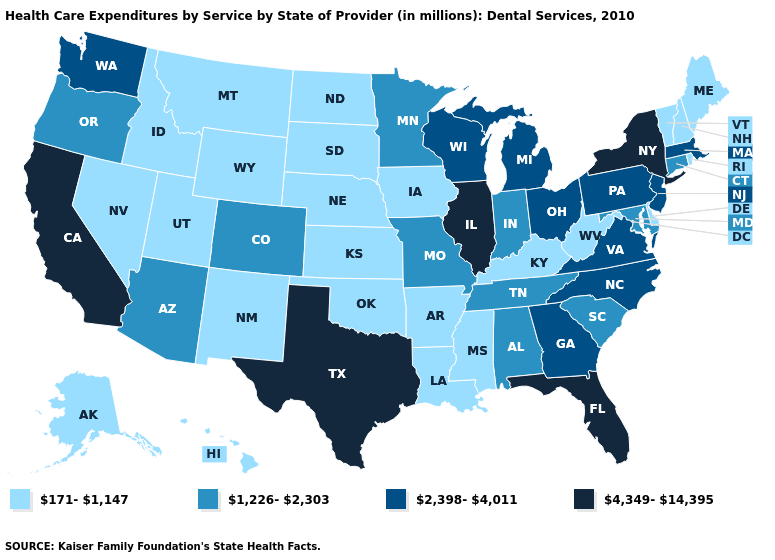Name the states that have a value in the range 171-1,147?
Write a very short answer. Alaska, Arkansas, Delaware, Hawaii, Idaho, Iowa, Kansas, Kentucky, Louisiana, Maine, Mississippi, Montana, Nebraska, Nevada, New Hampshire, New Mexico, North Dakota, Oklahoma, Rhode Island, South Dakota, Utah, Vermont, West Virginia, Wyoming. Which states have the lowest value in the Northeast?
Give a very brief answer. Maine, New Hampshire, Rhode Island, Vermont. Name the states that have a value in the range 4,349-14,395?
Concise answer only. California, Florida, Illinois, New York, Texas. Name the states that have a value in the range 171-1,147?
Write a very short answer. Alaska, Arkansas, Delaware, Hawaii, Idaho, Iowa, Kansas, Kentucky, Louisiana, Maine, Mississippi, Montana, Nebraska, Nevada, New Hampshire, New Mexico, North Dakota, Oklahoma, Rhode Island, South Dakota, Utah, Vermont, West Virginia, Wyoming. What is the value of Oregon?
Quick response, please. 1,226-2,303. Name the states that have a value in the range 4,349-14,395?
Write a very short answer. California, Florida, Illinois, New York, Texas. How many symbols are there in the legend?
Be succinct. 4. What is the lowest value in the USA?
Short answer required. 171-1,147. Among the states that border South Carolina , which have the lowest value?
Write a very short answer. Georgia, North Carolina. Among the states that border Alabama , which have the highest value?
Give a very brief answer. Florida. Among the states that border New York , which have the lowest value?
Be succinct. Vermont. Which states have the lowest value in the South?
Be succinct. Arkansas, Delaware, Kentucky, Louisiana, Mississippi, Oklahoma, West Virginia. Does South Dakota have a lower value than Connecticut?
Answer briefly. Yes. Which states hav the highest value in the MidWest?
Be succinct. Illinois. Does New York have the highest value in the Northeast?
Be succinct. Yes. 